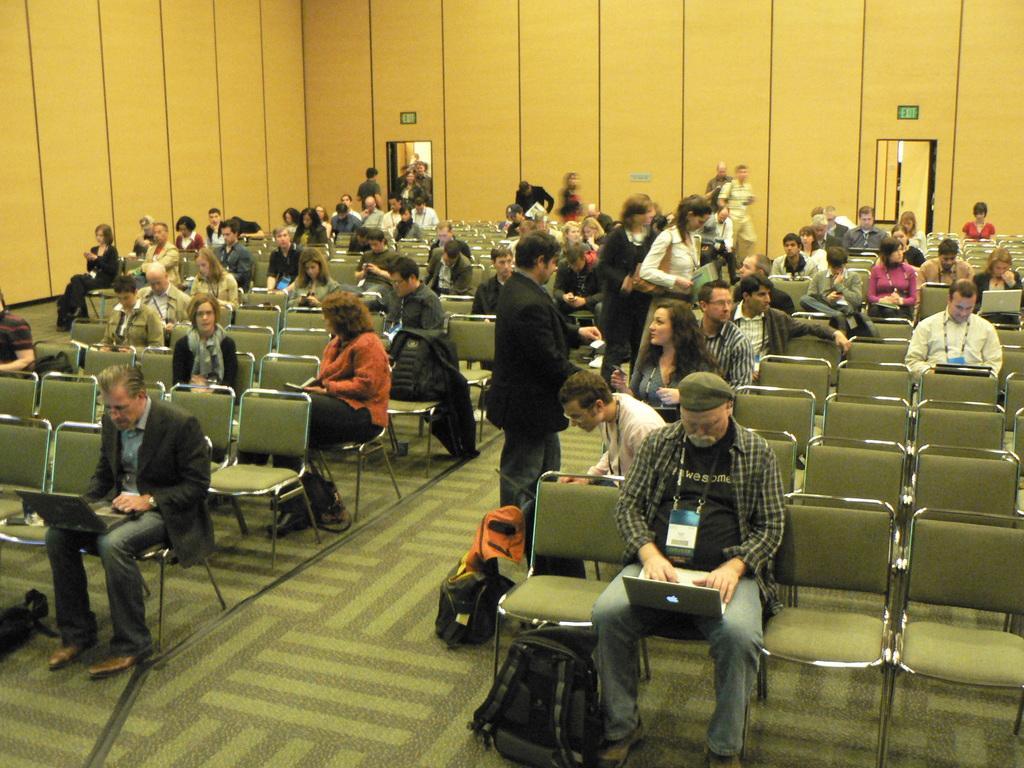How would you summarize this image in a sentence or two? In this image few persons are sitting on the chairs. Few persons are standing on the floor having few bags on it. Left side there is a person wearing a suit is having a laptop on his lap. Left side there is a person wearing a cap is having laptop on his lap. Before him there is a bag on the floor. Background there are two doors to the wall. 